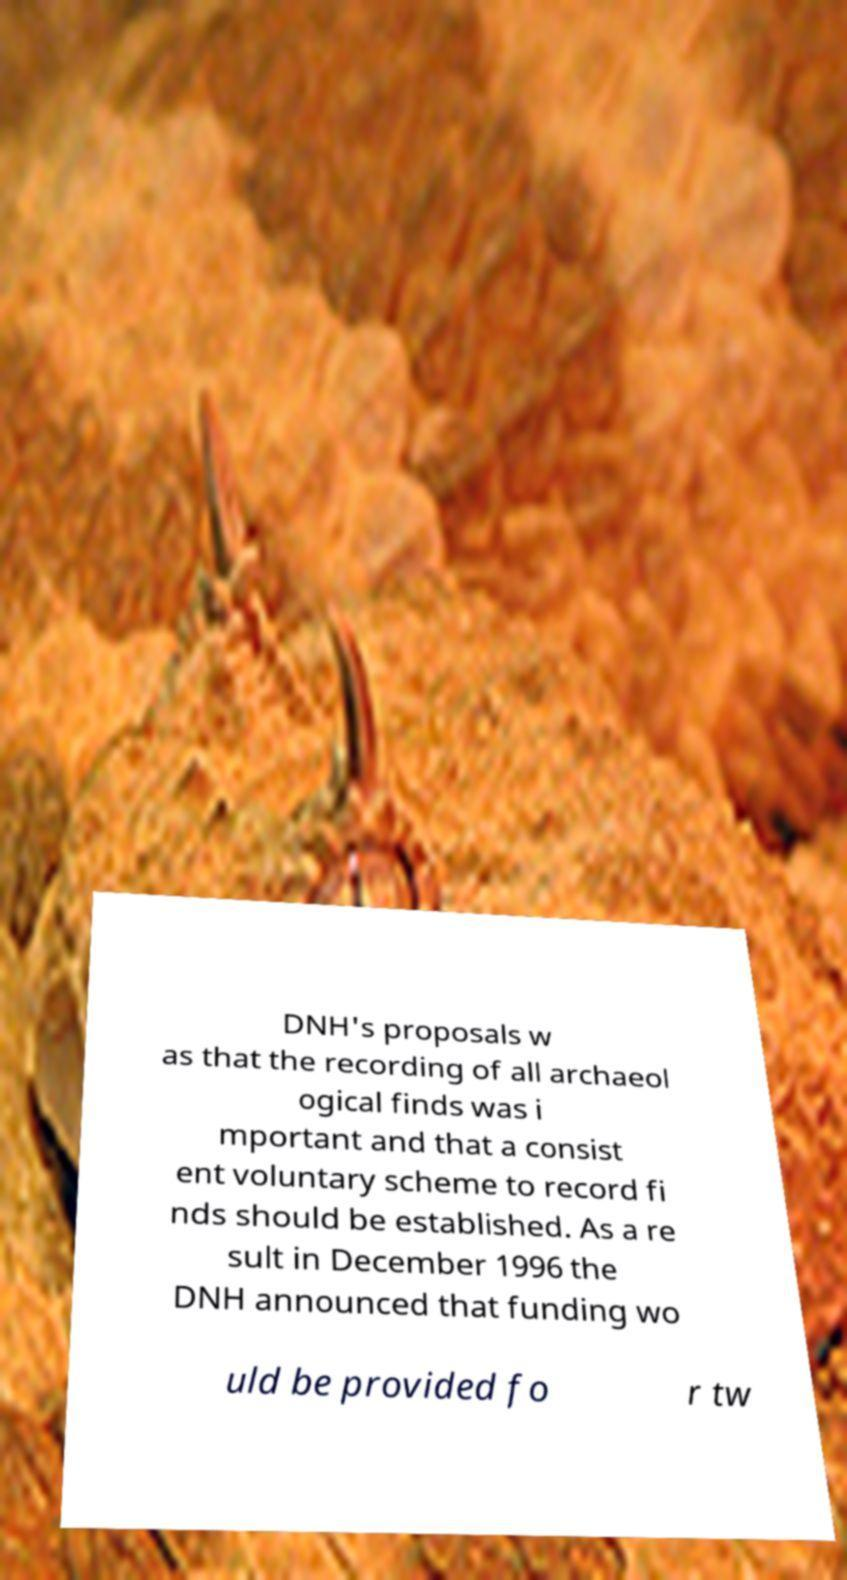Could you assist in decoding the text presented in this image and type it out clearly? DNH's proposals w as that the recording of all archaeol ogical finds was i mportant and that a consist ent voluntary scheme to record fi nds should be established. As a re sult in December 1996 the DNH announced that funding wo uld be provided fo r tw 